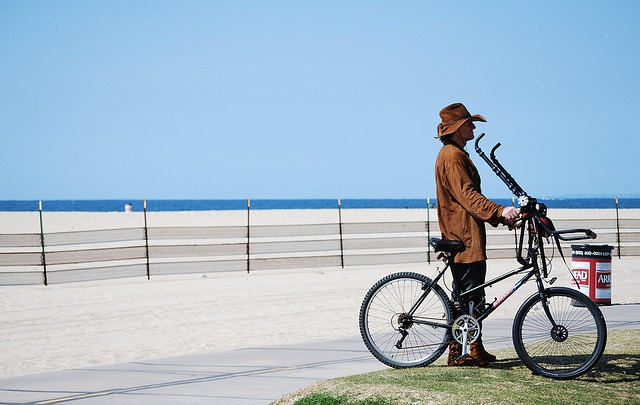Describe the objects in this image and their specific colors. I can see bicycle in lightblue, black, lightgray, darkgray, and gray tones and people in lightblue, black, maroon, and brown tones in this image. 